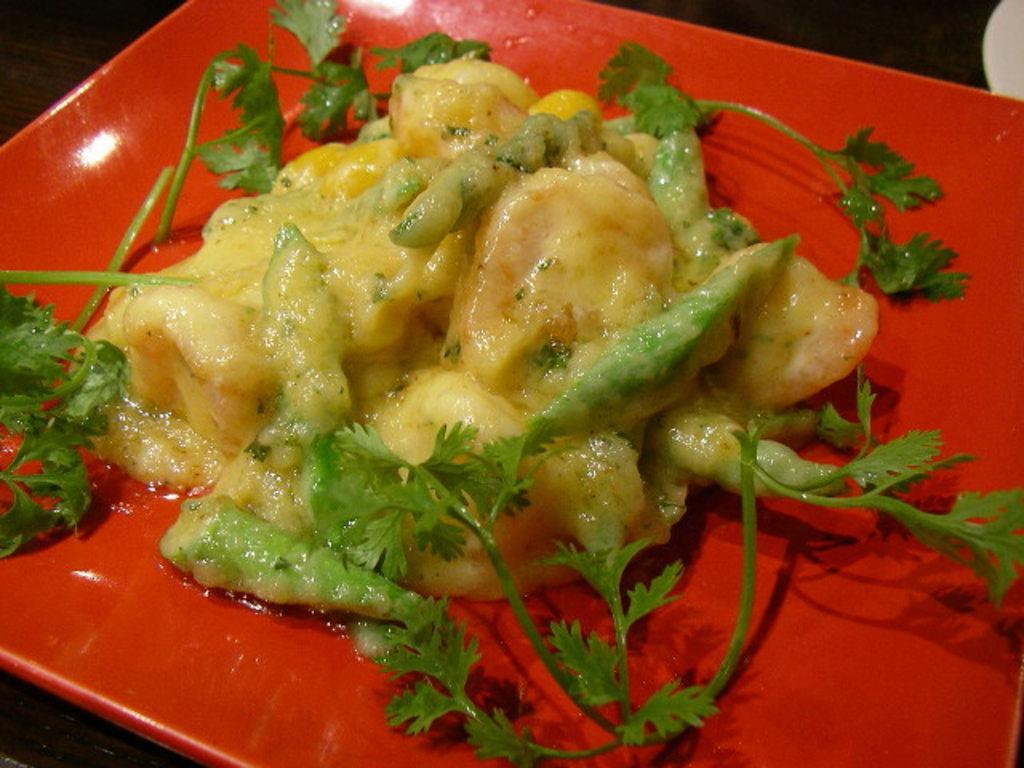In one or two sentences, can you explain what this image depicts? In this picture we can see a red color plate, there is some food and mint leaves present in the plate. 